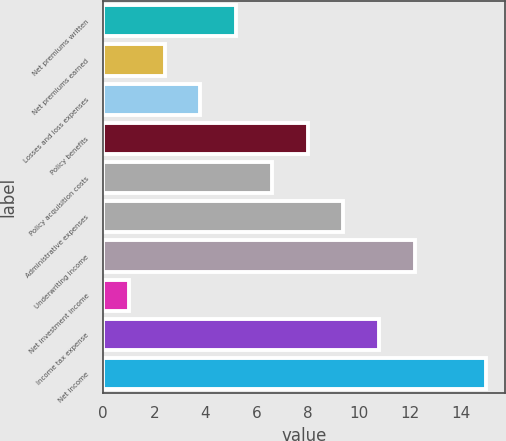Convert chart. <chart><loc_0><loc_0><loc_500><loc_500><bar_chart><fcel>Net premiums written<fcel>Net premiums earned<fcel>Losses and loss expenses<fcel>Policy benefits<fcel>Policy acquisition costs<fcel>Administrative expenses<fcel>Underwriting income<fcel>Net investment income<fcel>Income tax expense<fcel>Net income<nl><fcel>5.2<fcel>2.4<fcel>3.8<fcel>8<fcel>6.6<fcel>9.4<fcel>12.2<fcel>1<fcel>10.8<fcel>15<nl></chart> 